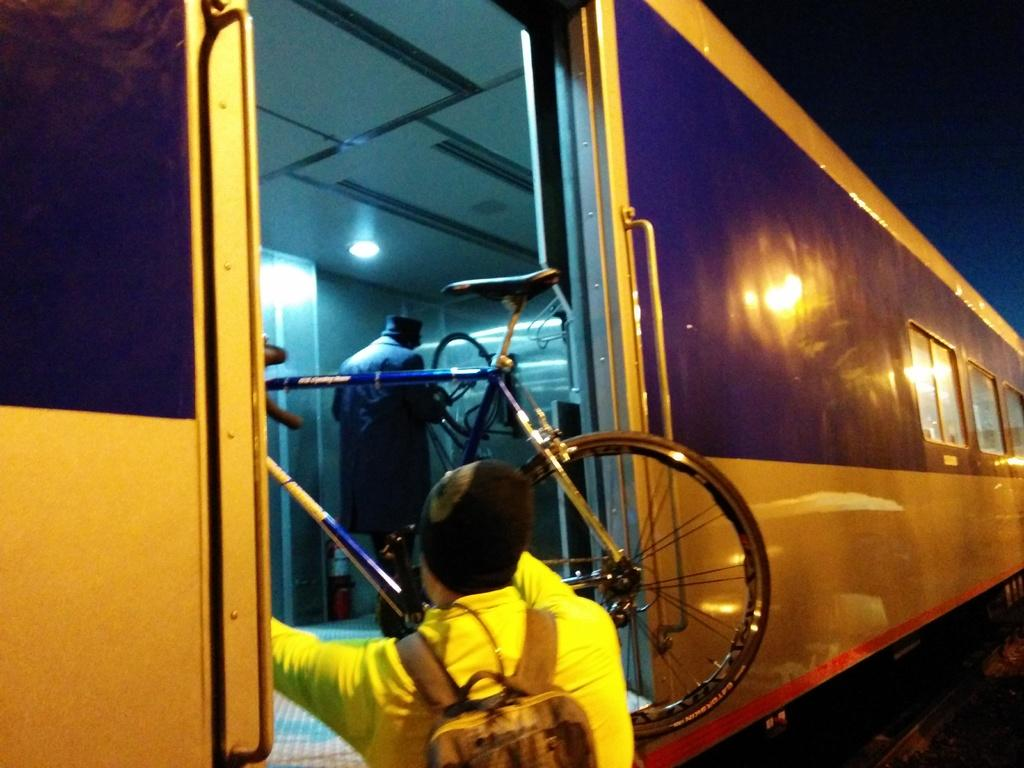Who is present in the image? There is a man in the image. What is the man doing in the image? The man is standing in the image. What is the man wearing in the image? The man is wearing a yellow dress in the image. What is the man carrying in the image? The man is carrying a bag in the image. What is the man holding in the image? The man is holding a bicycle in the image. Where is the man keeping the bicycle in the image? The man is keeping the bicycle in a train in the image. What type of beef is being cooked by the man in the image? There is no beef present in the image; the man is holding a bicycle and wearing a yellow dress. 